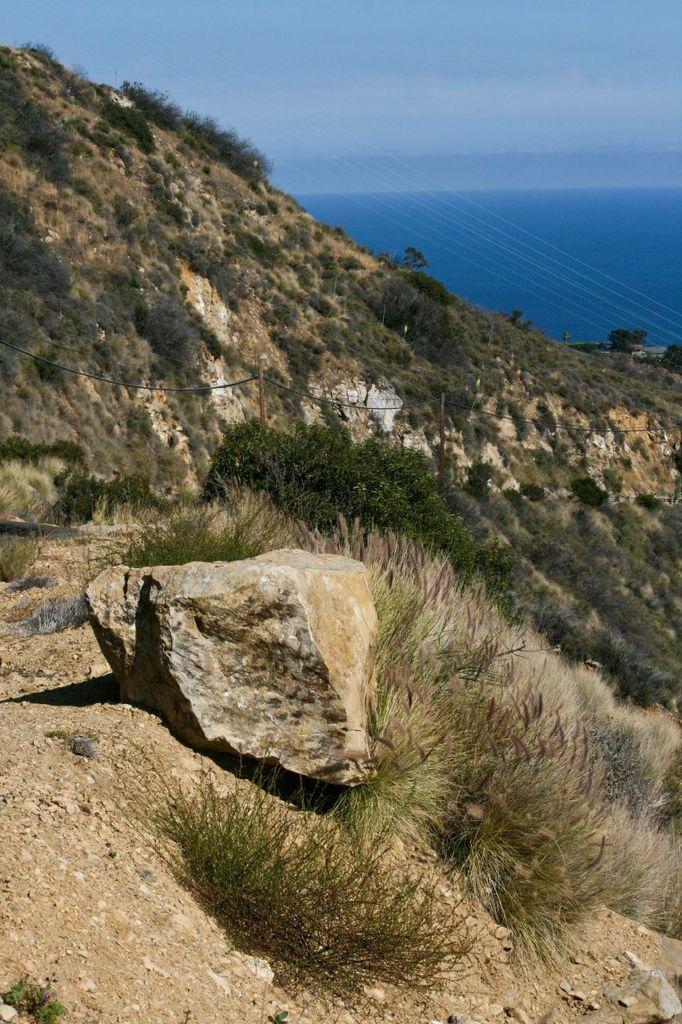How would you summarize this image in a sentence or two? In this image we can see there is a mountain with trees and rocks also there is beautiful view of sky. 